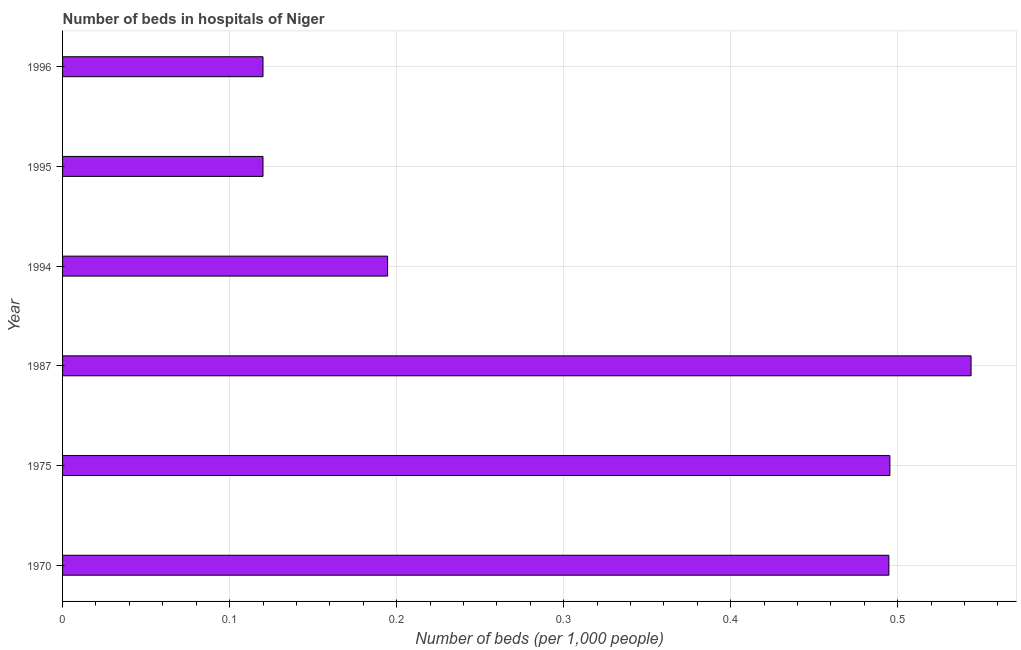Does the graph contain grids?
Your response must be concise. Yes. What is the title of the graph?
Offer a very short reply. Number of beds in hospitals of Niger. What is the label or title of the X-axis?
Provide a short and direct response. Number of beds (per 1,0 people). What is the label or title of the Y-axis?
Make the answer very short. Year. What is the number of hospital beds in 1975?
Give a very brief answer. 0.5. Across all years, what is the maximum number of hospital beds?
Make the answer very short. 0.54. Across all years, what is the minimum number of hospital beds?
Offer a very short reply. 0.12. What is the sum of the number of hospital beds?
Give a very brief answer. 1.97. What is the average number of hospital beds per year?
Offer a very short reply. 0.33. What is the median number of hospital beds?
Provide a succinct answer. 0.34. In how many years, is the number of hospital beds greater than 0.18 %?
Your answer should be very brief. 4. What is the ratio of the number of hospital beds in 1970 to that in 1987?
Keep it short and to the point. 0.91. Is the number of hospital beds in 1970 less than that in 1987?
Give a very brief answer. Yes. Is the difference between the number of hospital beds in 1994 and 1996 greater than the difference between any two years?
Provide a succinct answer. No. What is the difference between the highest and the second highest number of hospital beds?
Provide a succinct answer. 0.05. What is the difference between the highest and the lowest number of hospital beds?
Make the answer very short. 0.42. Are all the bars in the graph horizontal?
Your answer should be very brief. Yes. What is the difference between two consecutive major ticks on the X-axis?
Make the answer very short. 0.1. Are the values on the major ticks of X-axis written in scientific E-notation?
Ensure brevity in your answer.  No. What is the Number of beds (per 1,000 people) in 1970?
Provide a succinct answer. 0.49. What is the Number of beds (per 1,000 people) in 1975?
Your answer should be compact. 0.5. What is the Number of beds (per 1,000 people) in 1987?
Ensure brevity in your answer.  0.54. What is the Number of beds (per 1,000 people) in 1994?
Offer a terse response. 0.19. What is the Number of beds (per 1,000 people) of 1995?
Keep it short and to the point. 0.12. What is the Number of beds (per 1,000 people) in 1996?
Provide a short and direct response. 0.12. What is the difference between the Number of beds (per 1,000 people) in 1970 and 1975?
Your answer should be very brief. -0. What is the difference between the Number of beds (per 1,000 people) in 1970 and 1987?
Give a very brief answer. -0.05. What is the difference between the Number of beds (per 1,000 people) in 1970 and 1994?
Make the answer very short. 0.3. What is the difference between the Number of beds (per 1,000 people) in 1970 and 1995?
Give a very brief answer. 0.37. What is the difference between the Number of beds (per 1,000 people) in 1970 and 1996?
Your response must be concise. 0.37. What is the difference between the Number of beds (per 1,000 people) in 1975 and 1987?
Provide a short and direct response. -0.05. What is the difference between the Number of beds (per 1,000 people) in 1975 and 1994?
Make the answer very short. 0.3. What is the difference between the Number of beds (per 1,000 people) in 1975 and 1995?
Make the answer very short. 0.38. What is the difference between the Number of beds (per 1,000 people) in 1975 and 1996?
Provide a succinct answer. 0.38. What is the difference between the Number of beds (per 1,000 people) in 1987 and 1994?
Your response must be concise. 0.35. What is the difference between the Number of beds (per 1,000 people) in 1987 and 1995?
Provide a succinct answer. 0.42. What is the difference between the Number of beds (per 1,000 people) in 1987 and 1996?
Offer a terse response. 0.42. What is the difference between the Number of beds (per 1,000 people) in 1994 and 1995?
Give a very brief answer. 0.07. What is the difference between the Number of beds (per 1,000 people) in 1994 and 1996?
Keep it short and to the point. 0.07. What is the ratio of the Number of beds (per 1,000 people) in 1970 to that in 1987?
Ensure brevity in your answer.  0.91. What is the ratio of the Number of beds (per 1,000 people) in 1970 to that in 1994?
Your answer should be compact. 2.54. What is the ratio of the Number of beds (per 1,000 people) in 1970 to that in 1995?
Your answer should be compact. 4.12. What is the ratio of the Number of beds (per 1,000 people) in 1970 to that in 1996?
Ensure brevity in your answer.  4.12. What is the ratio of the Number of beds (per 1,000 people) in 1975 to that in 1987?
Offer a terse response. 0.91. What is the ratio of the Number of beds (per 1,000 people) in 1975 to that in 1994?
Ensure brevity in your answer.  2.54. What is the ratio of the Number of beds (per 1,000 people) in 1975 to that in 1995?
Make the answer very short. 4.13. What is the ratio of the Number of beds (per 1,000 people) in 1975 to that in 1996?
Your response must be concise. 4.13. What is the ratio of the Number of beds (per 1,000 people) in 1987 to that in 1994?
Your answer should be very brief. 2.79. What is the ratio of the Number of beds (per 1,000 people) in 1987 to that in 1995?
Provide a short and direct response. 4.53. What is the ratio of the Number of beds (per 1,000 people) in 1987 to that in 1996?
Make the answer very short. 4.53. What is the ratio of the Number of beds (per 1,000 people) in 1994 to that in 1995?
Provide a succinct answer. 1.62. What is the ratio of the Number of beds (per 1,000 people) in 1994 to that in 1996?
Ensure brevity in your answer.  1.62. What is the ratio of the Number of beds (per 1,000 people) in 1995 to that in 1996?
Your answer should be very brief. 1. 